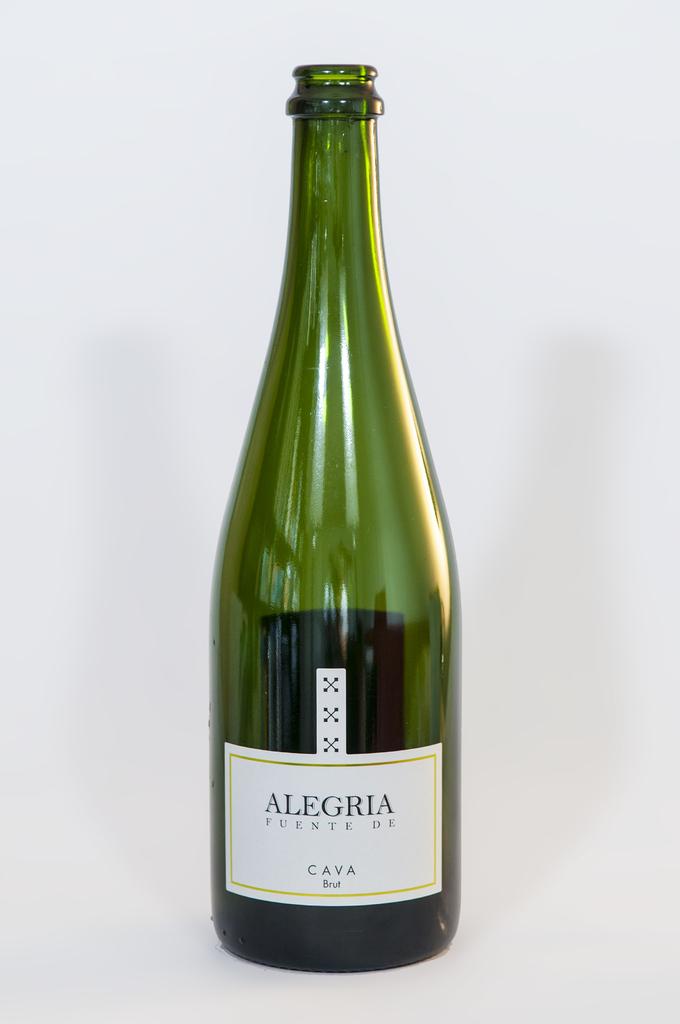What is the name of this wine?
Keep it short and to the point. Alegria. 